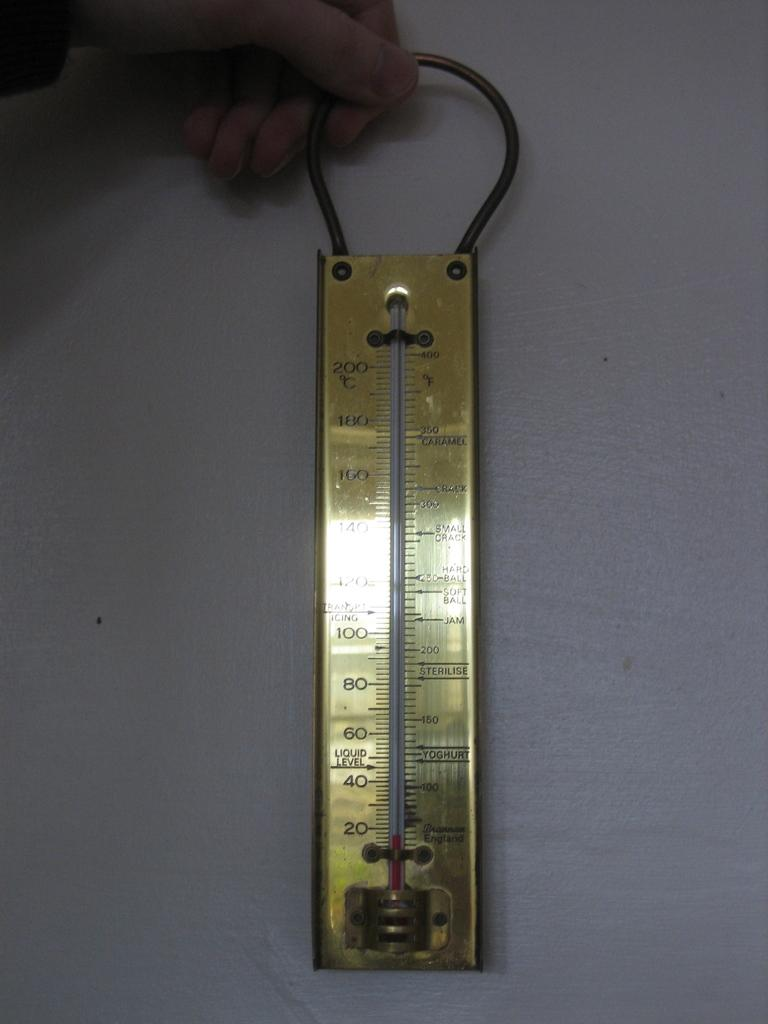<image>
Provide a brief description of the given image. A candy thermometer that was made in England has temperature markers for Caramel and Jam. 